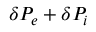<formula> <loc_0><loc_0><loc_500><loc_500>\delta P _ { e } + \delta P _ { i }</formula> 